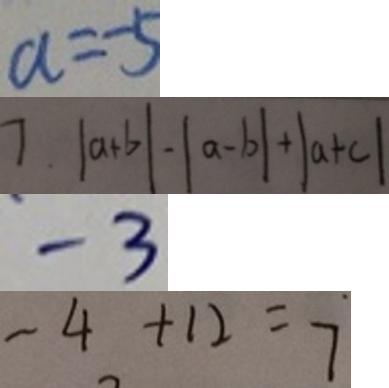Convert formula to latex. <formula><loc_0><loc_0><loc_500><loc_500>a = - 5 
 7 . \vert a + b \vert - \vert a - b \vert + \vert a + c \vert 
 - 3 
 - 4 + 1 2 = 7</formula> 